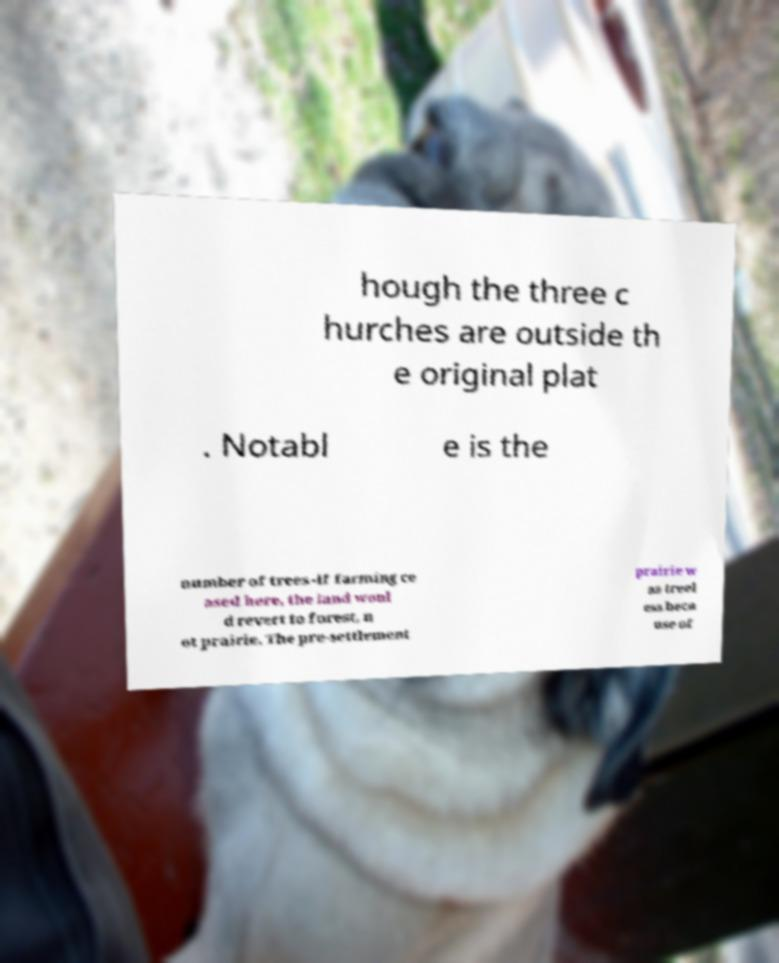Can you read and provide the text displayed in the image?This photo seems to have some interesting text. Can you extract and type it out for me? hough the three c hurches are outside th e original plat . Notabl e is the number of trees -if farming ce ased here, the land woul d revert to forest, n ot prairie. The pre-settlement prairie w as treel ess beca use of 